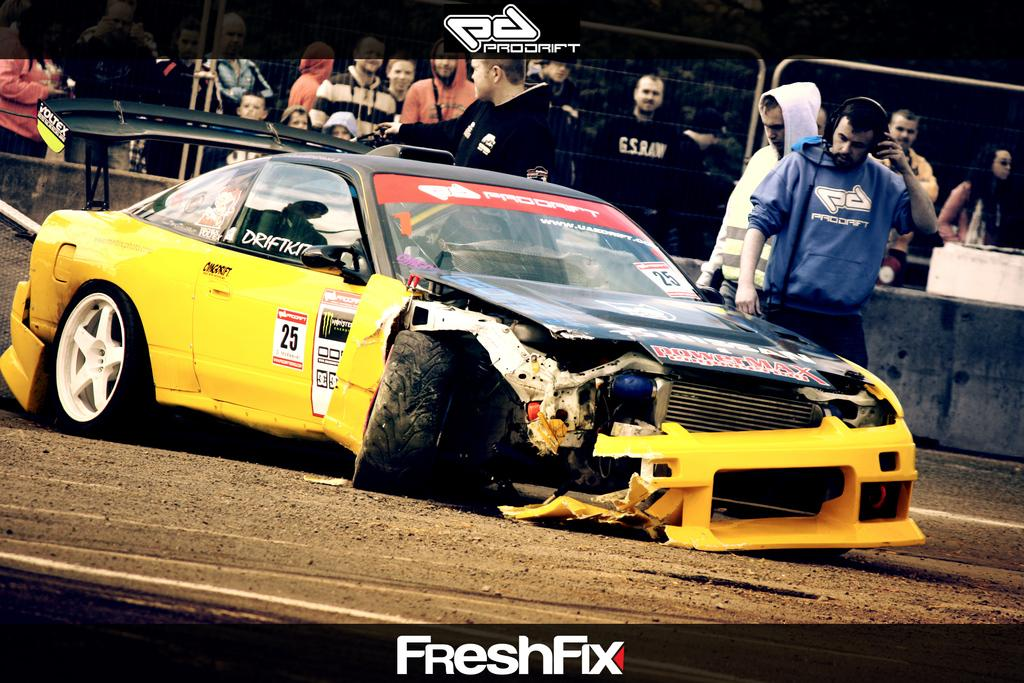What can be seen in the image involving transportation? There is a car in the image. What else is present in the image besides the car? There are people standing in the image. Is there any text visible in the image? Yes, there is text at the top and bottom of the image. Are the people in the image playing a guitar together? There is no guitar present in the image, and the people's actions are not described, so it cannot be determined if they are playing a guitar together. 